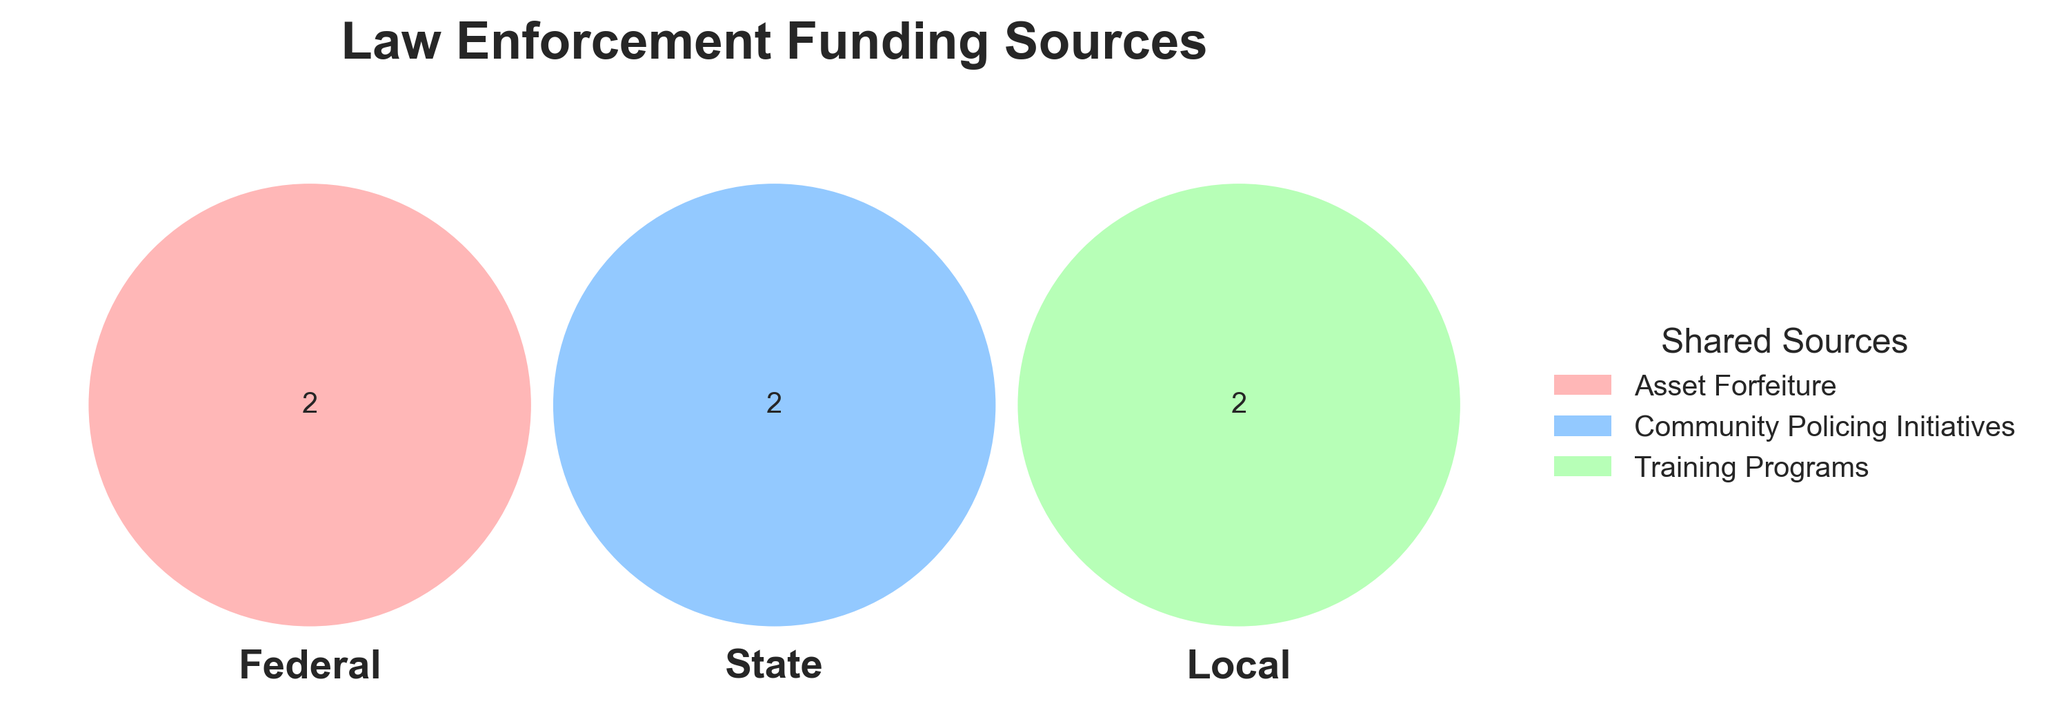What are the funding sources listed for the Federal category? The Federal category's funding sources are indicated separately in one of the Venn diagram circles.
Answer: Department of Justice Grants, Homeland Security Grants Which funding sources are shared between categories? Funding sources shared among Federal, State, or Local are listed in the legend or segment where these categories overlap in the Venn diagram.
Answer: Asset Forfeiture, Community Policing Initiatives, Training Programs How many shared funding sources are there? Look at the legend or count the items listed where Federal, State, and Local categories overlap in the diagram.
Answer: 3 Which category has a unique funding source from Property Taxes? Identify the circle that contains Property Taxes without any overlap with the other circles.
Answer: Local Does Homeland Security Grants overlap with any other category? Look for Homeland Security Grants in the Venn diagram to see if it is positioned within any overlapping segments of the circles.
Answer: No What combinations of categories include Community Policing Initiatives? Locate Community Policing Initiatives in the diagram and identify the segments or legend listing to understand which categories it falls under.
Answer: Shared (Federal, State, and Local) Is the State Police Budget exclusive to the State category? Find the State Police Budget in the diagram and see if it lies within the State circle or overlaps with other circles.
Answer: Yes How many total categories contribute to the Training Programs funding source? Check the legend or the overlapping segments of the circles that involve Training Programs.
Answer: 3 Which category does the Criminal Justice Improvement Funds belong to? Identify where the Criminal Justice Improvement Funds appear within the individual circles.
Answer: State What's the total number of unique funding sources across all categories? Count each distinct funding source within the diagram or sum the elements listed in each category without double-counting shared sources.
Answer: 9 